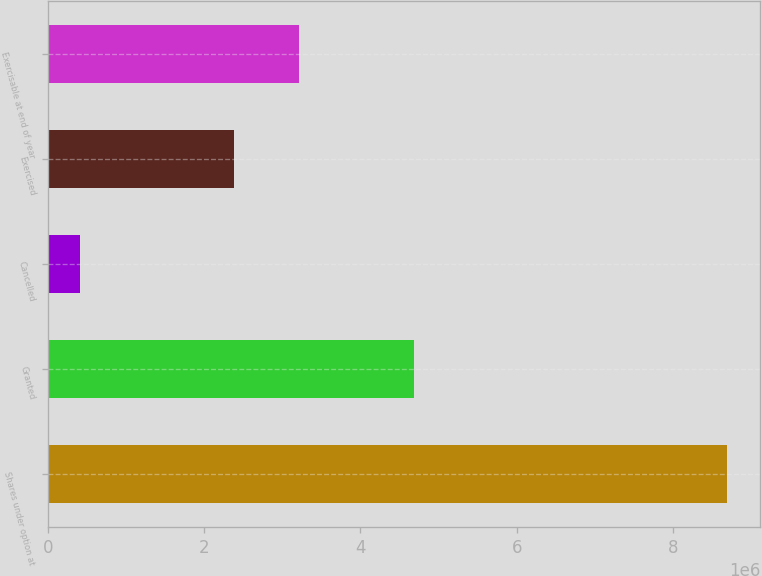Convert chart. <chart><loc_0><loc_0><loc_500><loc_500><bar_chart><fcel>Shares under option at<fcel>Granted<fcel>Cancelled<fcel>Exercised<fcel>Exercisable at end of year<nl><fcel>8.68168e+06<fcel>4.68e+06<fcel>415396<fcel>2.38643e+06<fcel>3.21305e+06<nl></chart> 